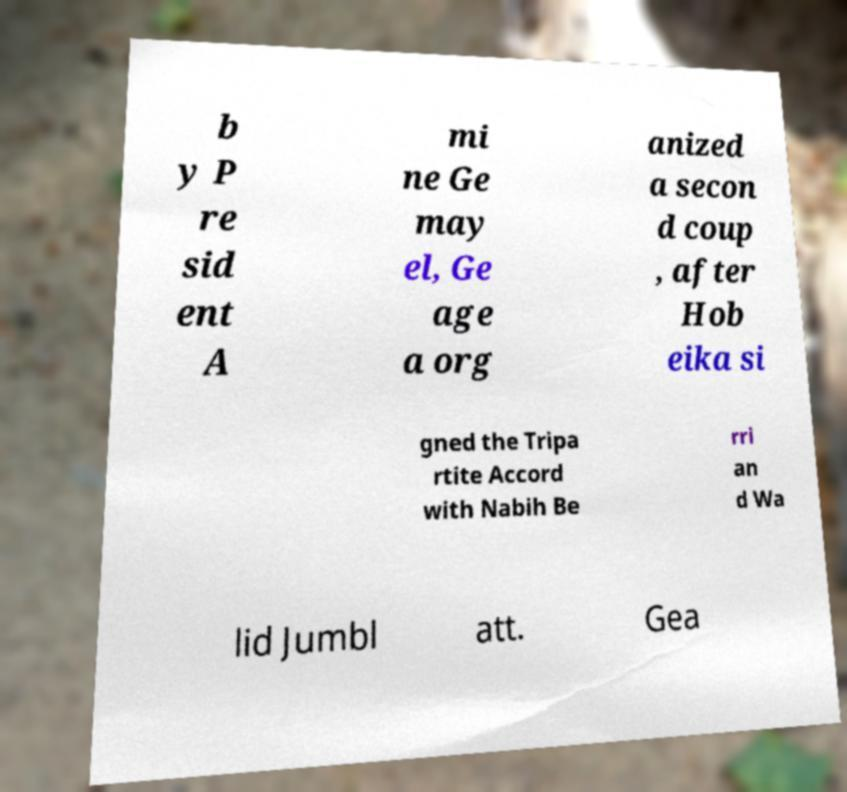What messages or text are displayed in this image? I need them in a readable, typed format. b y P re sid ent A mi ne Ge may el, Ge age a org anized a secon d coup , after Hob eika si gned the Tripa rtite Accord with Nabih Be rri an d Wa lid Jumbl att. Gea 